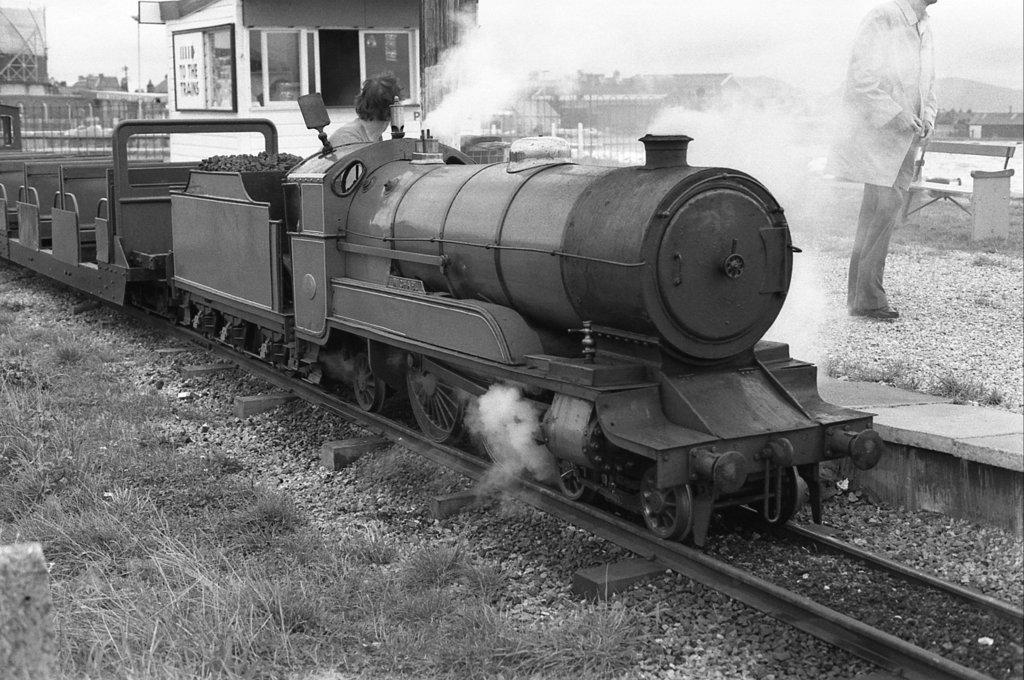<image>
Share a concise interpretation of the image provided. An old steam train pulls into station with a sign displaying an arrow and the text "To the trains" on it. 